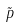Convert formula to latex. <formula><loc_0><loc_0><loc_500><loc_500>\tilde { p }</formula> 